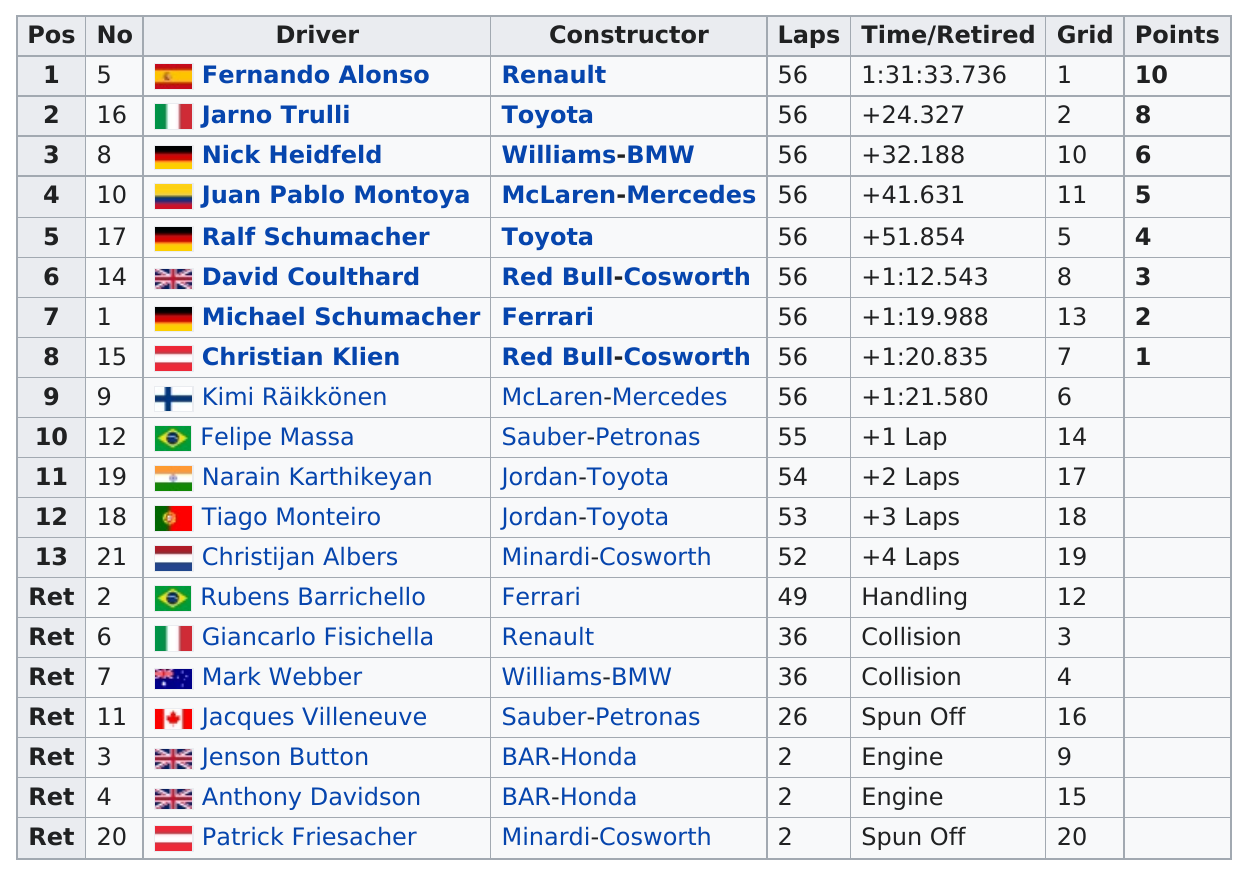Highlight a few significant elements in this photo. Christijan Albers was the last driver to actually complete the race. Fernando Alonso finished the race in a time of 1 hour and 31 minutes and 33.736 seconds. It took Nick Heidfeld 1 hour and 31 minutes and 65.924 seconds to finish. Two Germans placed in the top five. The winner of the first position completed a total of 56 laps. 